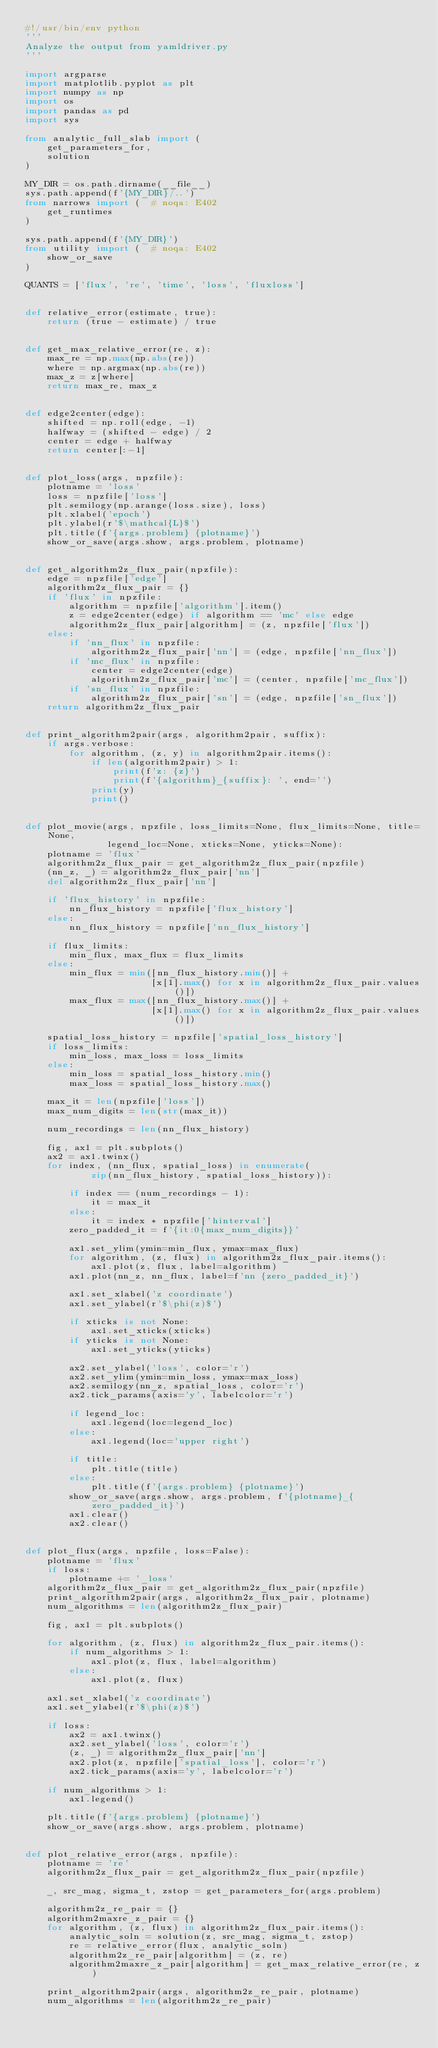<code> <loc_0><loc_0><loc_500><loc_500><_Python_>#!/usr/bin/env python
'''
Analyze the output from yamldriver.py
'''

import argparse
import matplotlib.pyplot as plt
import numpy as np
import os
import pandas as pd
import sys

from analytic_full_slab import (
    get_parameters_for,
    solution
)

MY_DIR = os.path.dirname(__file__)
sys.path.append(f'{MY_DIR}/..')
from narrows import (  # noqa: E402
    get_runtimes
)

sys.path.append(f'{MY_DIR}')
from utility import (  # noqa: E402
    show_or_save
)

QUANTS = ['flux', 're', 'time', 'loss', 'fluxloss']


def relative_error(estimate, true):
    return (true - estimate) / true


def get_max_relative_error(re, z):
    max_re = np.max(np.abs(re))
    where = np.argmax(np.abs(re))
    max_z = z[where]
    return max_re, max_z


def edge2center(edge):
    shifted = np.roll(edge, -1)
    halfway = (shifted - edge) / 2
    center = edge + halfway
    return center[:-1]


def plot_loss(args, npzfile):
    plotname = 'loss'
    loss = npzfile['loss']
    plt.semilogy(np.arange(loss.size), loss)
    plt.xlabel('epoch')
    plt.ylabel(r'$\mathcal{L}$')
    plt.title(f'{args.problem} {plotname}')
    show_or_save(args.show, args.problem, plotname)


def get_algorithm2z_flux_pair(npzfile):
    edge = npzfile['edge']
    algorithm2z_flux_pair = {}
    if 'flux' in npzfile:
        algorithm = npzfile['algorithm'].item()
        z = edge2center(edge) if algorithm == 'mc' else edge
        algorithm2z_flux_pair[algorithm] = (z, npzfile['flux'])
    else:
        if 'nn_flux' in npzfile:
            algorithm2z_flux_pair['nn'] = (edge, npzfile['nn_flux'])
        if 'mc_flux' in npzfile:
            center = edge2center(edge)
            algorithm2z_flux_pair['mc'] = (center, npzfile['mc_flux'])
        if 'sn_flux' in npzfile:
            algorithm2z_flux_pair['sn'] = (edge, npzfile['sn_flux'])
    return algorithm2z_flux_pair


def print_algorithm2pair(args, algorithm2pair, suffix):
    if args.verbose:
        for algorithm, (z, y) in algorithm2pair.items():
            if len(algorithm2pair) > 1:
                print(f'z: {z}')
                print(f'{algorithm}_{suffix}: ', end='')
            print(y)
            print()


def plot_movie(args, npzfile, loss_limits=None, flux_limits=None, title=None,
               legend_loc=None, xticks=None, yticks=None):
    plotname = 'flux'
    algorithm2z_flux_pair = get_algorithm2z_flux_pair(npzfile)
    (nn_z, _) = algorithm2z_flux_pair['nn']
    del algorithm2z_flux_pair['nn']

    if 'flux_history' in npzfile:
        nn_flux_history = npzfile['flux_history']
    else:
        nn_flux_history = npzfile['nn_flux_history']

    if flux_limits:
        min_flux, max_flux = flux_limits
    else:
        min_flux = min([nn_flux_history.min()] +
                       [x[1].max() for x in algorithm2z_flux_pair.values()])
        max_flux = max([nn_flux_history.max()] +
                       [x[1].max() for x in algorithm2z_flux_pair.values()])

    spatial_loss_history = npzfile['spatial_loss_history']
    if loss_limits:
        min_loss, max_loss = loss_limits
    else:
        min_loss = spatial_loss_history.min()
        max_loss = spatial_loss_history.max()

    max_it = len(npzfile['loss'])
    max_num_digits = len(str(max_it))

    num_recordings = len(nn_flux_history)

    fig, ax1 = plt.subplots()
    ax2 = ax1.twinx()
    for index, (nn_flux, spatial_loss) in enumerate(
            zip(nn_flux_history, spatial_loss_history)):

        if index == (num_recordings - 1):
            it = max_it
        else:
            it = index * npzfile['hinterval']
        zero_padded_it = f'{it:0{max_num_digits}}'

        ax1.set_ylim(ymin=min_flux, ymax=max_flux)
        for algorithm, (z, flux) in algorithm2z_flux_pair.items():
            ax1.plot(z, flux, label=algorithm)
        ax1.plot(nn_z, nn_flux, label=f'nn {zero_padded_it}')

        ax1.set_xlabel('z coordinate')
        ax1.set_ylabel(r'$\phi(z)$')

        if xticks is not None:
            ax1.set_xticks(xticks)
        if yticks is not None:
            ax1.set_yticks(yticks)

        ax2.set_ylabel('loss', color='r')
        ax2.set_ylim(ymin=min_loss, ymax=max_loss)
        ax2.semilogy(nn_z, spatial_loss, color='r')
        ax2.tick_params(axis='y', labelcolor='r')

        if legend_loc:
            ax1.legend(loc=legend_loc)
        else:
            ax1.legend(loc='upper right')

        if title:
            plt.title(title)
        else:
            plt.title(f'{args.problem} {plotname}')
        show_or_save(args.show, args.problem, f'{plotname}_{zero_padded_it}')
        ax1.clear()
        ax2.clear()


def plot_flux(args, npzfile, loss=False):
    plotname = 'flux'
    if loss:
        plotname += '_loss'
    algorithm2z_flux_pair = get_algorithm2z_flux_pair(npzfile)
    print_algorithm2pair(args, algorithm2z_flux_pair, plotname)
    num_algorithms = len(algorithm2z_flux_pair)

    fig, ax1 = plt.subplots()

    for algorithm, (z, flux) in algorithm2z_flux_pair.items():
        if num_algorithms > 1:
            ax1.plot(z, flux, label=algorithm)
        else:
            ax1.plot(z, flux)

    ax1.set_xlabel('z coordinate')
    ax1.set_ylabel(r'$\phi(z)$')

    if loss:
        ax2 = ax1.twinx()
        ax2.set_ylabel('loss', color='r')
        (z, _) = algorithm2z_flux_pair['nn']
        ax2.plot(z, npzfile['spatial_loss'], color='r')
        ax2.tick_params(axis='y', labelcolor='r')

    if num_algorithms > 1:
        ax1.legend()

    plt.title(f'{args.problem} {plotname}')
    show_or_save(args.show, args.problem, plotname)


def plot_relative_error(args, npzfile):
    plotname = 're'
    algorithm2z_flux_pair = get_algorithm2z_flux_pair(npzfile)

    _, src_mag, sigma_t, zstop = get_parameters_for(args.problem)

    algorithm2z_re_pair = {}
    algorithm2maxre_z_pair = {}
    for algorithm, (z, flux) in algorithm2z_flux_pair.items():
        analytic_soln = solution(z, src_mag, sigma_t, zstop)
        re = relative_error(flux, analytic_soln)
        algorithm2z_re_pair[algorithm] = (z, re)
        algorithm2maxre_z_pair[algorithm] = get_max_relative_error(re, z)

    print_algorithm2pair(args, algorithm2z_re_pair, plotname)
    num_algorithms = len(algorithm2z_re_pair)
</code> 